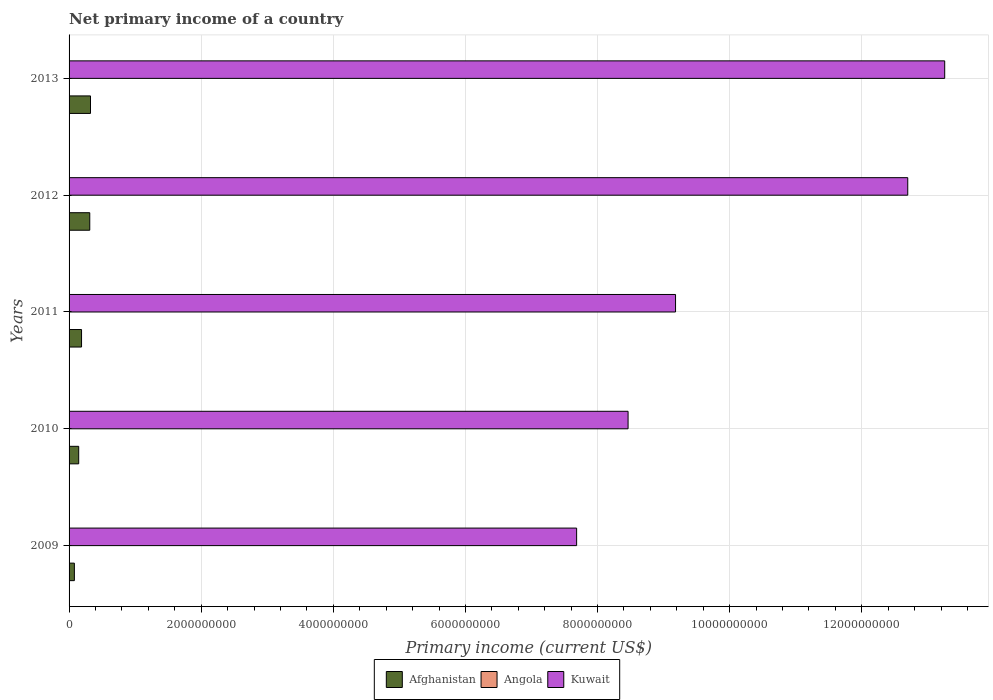How many different coloured bars are there?
Your response must be concise. 2. How many bars are there on the 3rd tick from the bottom?
Give a very brief answer. 2. What is the primary income in Afghanistan in 2013?
Offer a terse response. 3.24e+08. Across all years, what is the maximum primary income in Kuwait?
Offer a terse response. 1.33e+1. Across all years, what is the minimum primary income in Afghanistan?
Offer a terse response. 8.03e+07. In which year was the primary income in Kuwait maximum?
Give a very brief answer. 2013. What is the total primary income in Kuwait in the graph?
Your response must be concise. 5.13e+1. What is the difference between the primary income in Afghanistan in 2010 and that in 2011?
Your answer should be very brief. -4.31e+07. What is the difference between the primary income in Kuwait in 2013 and the primary income in Angola in 2012?
Make the answer very short. 1.33e+1. What is the average primary income in Angola per year?
Offer a terse response. 0. In the year 2010, what is the difference between the primary income in Afghanistan and primary income in Kuwait?
Provide a succinct answer. -8.32e+09. In how many years, is the primary income in Afghanistan greater than 4800000000 US$?
Your answer should be very brief. 0. What is the ratio of the primary income in Afghanistan in 2012 to that in 2013?
Offer a very short reply. 0.97. What is the difference between the highest and the second highest primary income in Kuwait?
Make the answer very short. 5.60e+08. What is the difference between the highest and the lowest primary income in Kuwait?
Your response must be concise. 5.57e+09. Is it the case that in every year, the sum of the primary income in Angola and primary income in Kuwait is greater than the primary income in Afghanistan?
Give a very brief answer. Yes. How many bars are there?
Your answer should be compact. 10. How many years are there in the graph?
Make the answer very short. 5. What is the difference between two consecutive major ticks on the X-axis?
Provide a succinct answer. 2.00e+09. Where does the legend appear in the graph?
Your answer should be very brief. Bottom center. How many legend labels are there?
Provide a succinct answer. 3. What is the title of the graph?
Your answer should be very brief. Net primary income of a country. What is the label or title of the X-axis?
Ensure brevity in your answer.  Primary income (current US$). What is the label or title of the Y-axis?
Provide a short and direct response. Years. What is the Primary income (current US$) in Afghanistan in 2009?
Make the answer very short. 8.03e+07. What is the Primary income (current US$) of Kuwait in 2009?
Make the answer very short. 7.68e+09. What is the Primary income (current US$) in Afghanistan in 2010?
Offer a very short reply. 1.46e+08. What is the Primary income (current US$) of Angola in 2010?
Your response must be concise. 0. What is the Primary income (current US$) in Kuwait in 2010?
Your response must be concise. 8.46e+09. What is the Primary income (current US$) of Afghanistan in 2011?
Your answer should be compact. 1.89e+08. What is the Primary income (current US$) in Angola in 2011?
Your answer should be compact. 0. What is the Primary income (current US$) in Kuwait in 2011?
Offer a terse response. 9.18e+09. What is the Primary income (current US$) in Afghanistan in 2012?
Ensure brevity in your answer.  3.13e+08. What is the Primary income (current US$) in Kuwait in 2012?
Provide a short and direct response. 1.27e+1. What is the Primary income (current US$) of Afghanistan in 2013?
Provide a short and direct response. 3.24e+08. What is the Primary income (current US$) in Angola in 2013?
Your response must be concise. 0. What is the Primary income (current US$) in Kuwait in 2013?
Your answer should be very brief. 1.33e+1. Across all years, what is the maximum Primary income (current US$) of Afghanistan?
Provide a short and direct response. 3.24e+08. Across all years, what is the maximum Primary income (current US$) of Kuwait?
Ensure brevity in your answer.  1.33e+1. Across all years, what is the minimum Primary income (current US$) of Afghanistan?
Make the answer very short. 8.03e+07. Across all years, what is the minimum Primary income (current US$) in Kuwait?
Provide a succinct answer. 7.68e+09. What is the total Primary income (current US$) in Afghanistan in the graph?
Provide a succinct answer. 1.05e+09. What is the total Primary income (current US$) of Angola in the graph?
Provide a short and direct response. 0. What is the total Primary income (current US$) in Kuwait in the graph?
Offer a terse response. 5.13e+1. What is the difference between the Primary income (current US$) in Afghanistan in 2009 and that in 2010?
Give a very brief answer. -6.54e+07. What is the difference between the Primary income (current US$) in Kuwait in 2009 and that in 2010?
Make the answer very short. -7.79e+08. What is the difference between the Primary income (current US$) in Afghanistan in 2009 and that in 2011?
Provide a short and direct response. -1.08e+08. What is the difference between the Primary income (current US$) in Kuwait in 2009 and that in 2011?
Offer a terse response. -1.50e+09. What is the difference between the Primary income (current US$) of Afghanistan in 2009 and that in 2012?
Your response must be concise. -2.33e+08. What is the difference between the Primary income (current US$) in Kuwait in 2009 and that in 2012?
Your answer should be compact. -5.01e+09. What is the difference between the Primary income (current US$) of Afghanistan in 2009 and that in 2013?
Ensure brevity in your answer.  -2.44e+08. What is the difference between the Primary income (current US$) of Kuwait in 2009 and that in 2013?
Your response must be concise. -5.57e+09. What is the difference between the Primary income (current US$) in Afghanistan in 2010 and that in 2011?
Offer a terse response. -4.31e+07. What is the difference between the Primary income (current US$) of Kuwait in 2010 and that in 2011?
Offer a terse response. -7.18e+08. What is the difference between the Primary income (current US$) of Afghanistan in 2010 and that in 2012?
Provide a succinct answer. -1.67e+08. What is the difference between the Primary income (current US$) of Kuwait in 2010 and that in 2012?
Your answer should be very brief. -4.23e+09. What is the difference between the Primary income (current US$) of Afghanistan in 2010 and that in 2013?
Ensure brevity in your answer.  -1.79e+08. What is the difference between the Primary income (current US$) in Kuwait in 2010 and that in 2013?
Give a very brief answer. -4.79e+09. What is the difference between the Primary income (current US$) in Afghanistan in 2011 and that in 2012?
Provide a succinct answer. -1.24e+08. What is the difference between the Primary income (current US$) of Kuwait in 2011 and that in 2012?
Offer a terse response. -3.52e+09. What is the difference between the Primary income (current US$) in Afghanistan in 2011 and that in 2013?
Make the answer very short. -1.36e+08. What is the difference between the Primary income (current US$) of Kuwait in 2011 and that in 2013?
Your answer should be very brief. -4.07e+09. What is the difference between the Primary income (current US$) in Afghanistan in 2012 and that in 2013?
Offer a very short reply. -1.12e+07. What is the difference between the Primary income (current US$) of Kuwait in 2012 and that in 2013?
Ensure brevity in your answer.  -5.60e+08. What is the difference between the Primary income (current US$) of Afghanistan in 2009 and the Primary income (current US$) of Kuwait in 2010?
Make the answer very short. -8.38e+09. What is the difference between the Primary income (current US$) in Afghanistan in 2009 and the Primary income (current US$) in Kuwait in 2011?
Give a very brief answer. -9.10e+09. What is the difference between the Primary income (current US$) in Afghanistan in 2009 and the Primary income (current US$) in Kuwait in 2012?
Offer a terse response. -1.26e+1. What is the difference between the Primary income (current US$) of Afghanistan in 2009 and the Primary income (current US$) of Kuwait in 2013?
Offer a very short reply. -1.32e+1. What is the difference between the Primary income (current US$) of Afghanistan in 2010 and the Primary income (current US$) of Kuwait in 2011?
Offer a very short reply. -9.03e+09. What is the difference between the Primary income (current US$) in Afghanistan in 2010 and the Primary income (current US$) in Kuwait in 2012?
Make the answer very short. -1.25e+1. What is the difference between the Primary income (current US$) in Afghanistan in 2010 and the Primary income (current US$) in Kuwait in 2013?
Your response must be concise. -1.31e+1. What is the difference between the Primary income (current US$) of Afghanistan in 2011 and the Primary income (current US$) of Kuwait in 2012?
Offer a terse response. -1.25e+1. What is the difference between the Primary income (current US$) in Afghanistan in 2011 and the Primary income (current US$) in Kuwait in 2013?
Make the answer very short. -1.31e+1. What is the difference between the Primary income (current US$) of Afghanistan in 2012 and the Primary income (current US$) of Kuwait in 2013?
Give a very brief answer. -1.29e+1. What is the average Primary income (current US$) in Afghanistan per year?
Your response must be concise. 2.10e+08. What is the average Primary income (current US$) of Kuwait per year?
Your answer should be compact. 1.03e+1. In the year 2009, what is the difference between the Primary income (current US$) in Afghanistan and Primary income (current US$) in Kuwait?
Make the answer very short. -7.60e+09. In the year 2010, what is the difference between the Primary income (current US$) of Afghanistan and Primary income (current US$) of Kuwait?
Your response must be concise. -8.32e+09. In the year 2011, what is the difference between the Primary income (current US$) in Afghanistan and Primary income (current US$) in Kuwait?
Ensure brevity in your answer.  -8.99e+09. In the year 2012, what is the difference between the Primary income (current US$) of Afghanistan and Primary income (current US$) of Kuwait?
Keep it short and to the point. -1.24e+1. In the year 2013, what is the difference between the Primary income (current US$) of Afghanistan and Primary income (current US$) of Kuwait?
Offer a very short reply. -1.29e+1. What is the ratio of the Primary income (current US$) in Afghanistan in 2009 to that in 2010?
Provide a succinct answer. 0.55. What is the ratio of the Primary income (current US$) in Kuwait in 2009 to that in 2010?
Your answer should be compact. 0.91. What is the ratio of the Primary income (current US$) of Afghanistan in 2009 to that in 2011?
Your answer should be compact. 0.43. What is the ratio of the Primary income (current US$) in Kuwait in 2009 to that in 2011?
Provide a succinct answer. 0.84. What is the ratio of the Primary income (current US$) of Afghanistan in 2009 to that in 2012?
Give a very brief answer. 0.26. What is the ratio of the Primary income (current US$) of Kuwait in 2009 to that in 2012?
Ensure brevity in your answer.  0.61. What is the ratio of the Primary income (current US$) in Afghanistan in 2009 to that in 2013?
Ensure brevity in your answer.  0.25. What is the ratio of the Primary income (current US$) of Kuwait in 2009 to that in 2013?
Your response must be concise. 0.58. What is the ratio of the Primary income (current US$) in Afghanistan in 2010 to that in 2011?
Offer a very short reply. 0.77. What is the ratio of the Primary income (current US$) in Kuwait in 2010 to that in 2011?
Offer a terse response. 0.92. What is the ratio of the Primary income (current US$) in Afghanistan in 2010 to that in 2012?
Give a very brief answer. 0.47. What is the ratio of the Primary income (current US$) of Kuwait in 2010 to that in 2012?
Your response must be concise. 0.67. What is the ratio of the Primary income (current US$) in Afghanistan in 2010 to that in 2013?
Your answer should be very brief. 0.45. What is the ratio of the Primary income (current US$) of Kuwait in 2010 to that in 2013?
Your answer should be very brief. 0.64. What is the ratio of the Primary income (current US$) of Afghanistan in 2011 to that in 2012?
Your answer should be very brief. 0.6. What is the ratio of the Primary income (current US$) of Kuwait in 2011 to that in 2012?
Provide a succinct answer. 0.72. What is the ratio of the Primary income (current US$) in Afghanistan in 2011 to that in 2013?
Provide a short and direct response. 0.58. What is the ratio of the Primary income (current US$) in Kuwait in 2011 to that in 2013?
Offer a terse response. 0.69. What is the ratio of the Primary income (current US$) of Afghanistan in 2012 to that in 2013?
Ensure brevity in your answer.  0.97. What is the ratio of the Primary income (current US$) in Kuwait in 2012 to that in 2013?
Your response must be concise. 0.96. What is the difference between the highest and the second highest Primary income (current US$) of Afghanistan?
Your response must be concise. 1.12e+07. What is the difference between the highest and the second highest Primary income (current US$) in Kuwait?
Ensure brevity in your answer.  5.60e+08. What is the difference between the highest and the lowest Primary income (current US$) in Afghanistan?
Offer a very short reply. 2.44e+08. What is the difference between the highest and the lowest Primary income (current US$) of Kuwait?
Make the answer very short. 5.57e+09. 